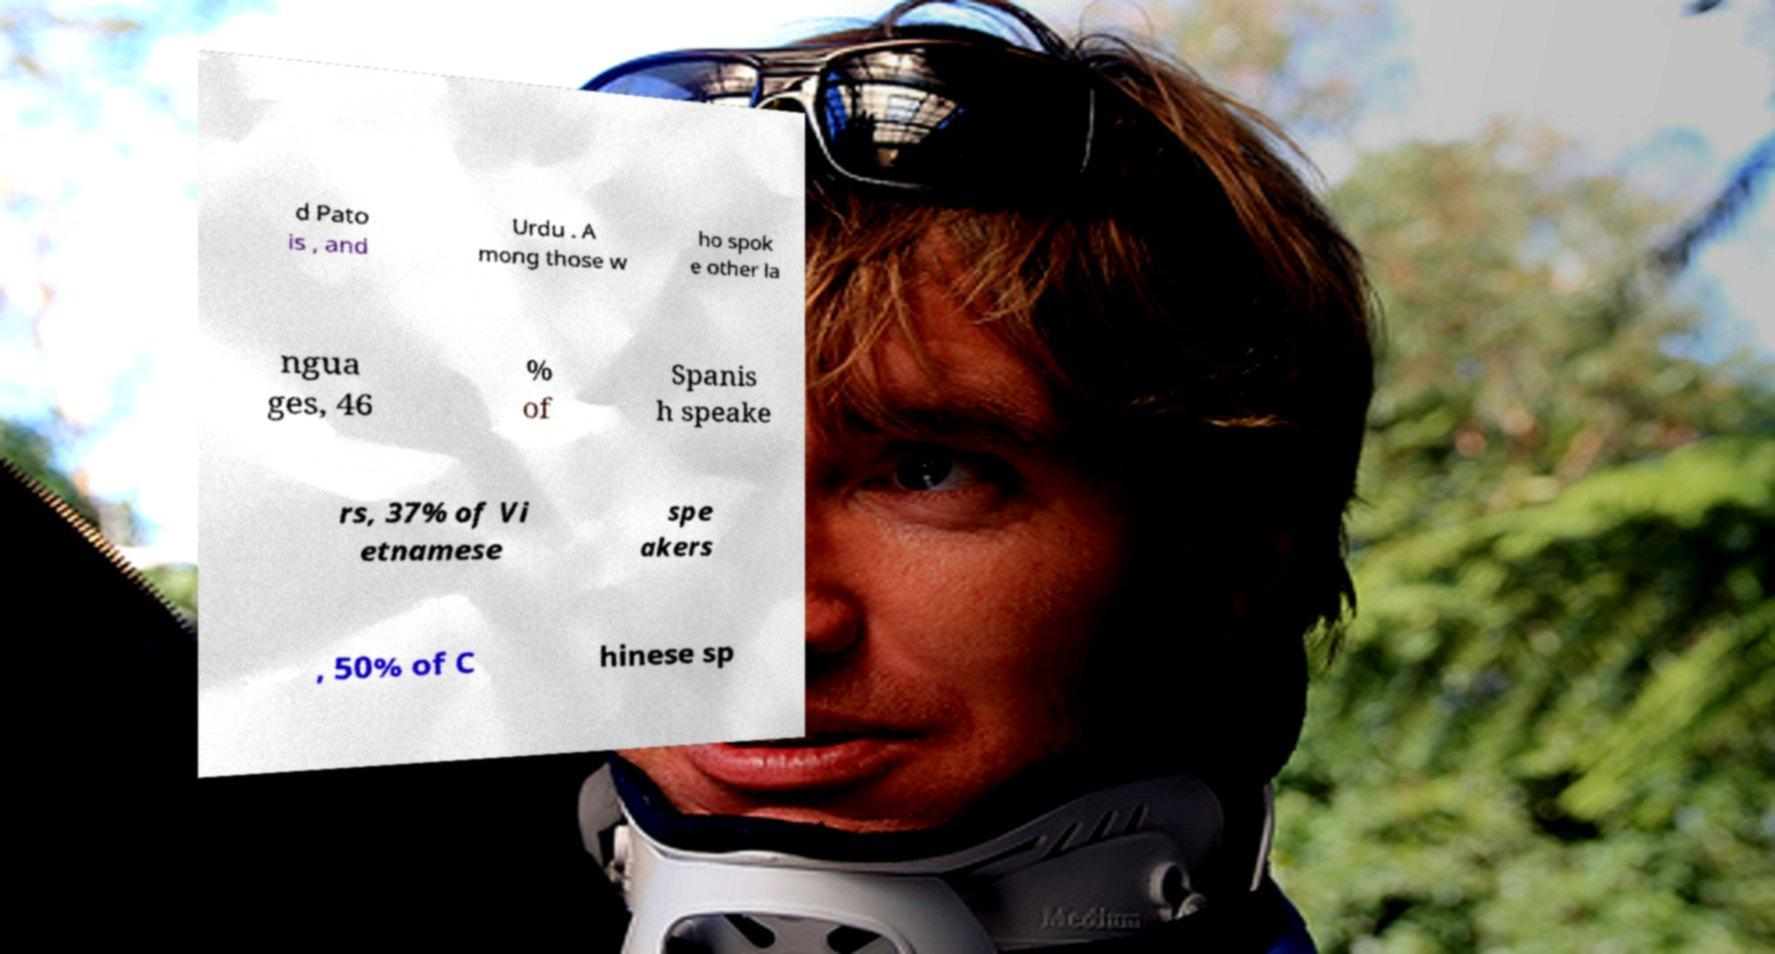Could you assist in decoding the text presented in this image and type it out clearly? d Pato is , and Urdu . A mong those w ho spok e other la ngua ges, 46 % of Spanis h speake rs, 37% of Vi etnamese spe akers , 50% of C hinese sp 